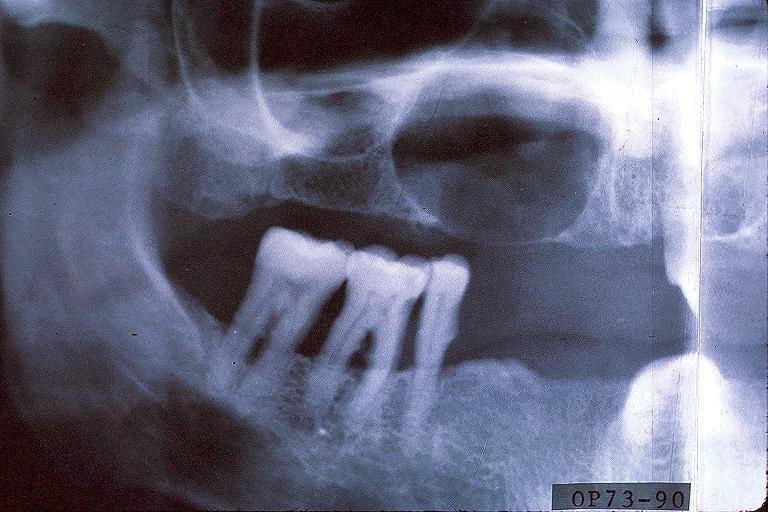what is present?
Answer the question using a single word or phrase. Oral 